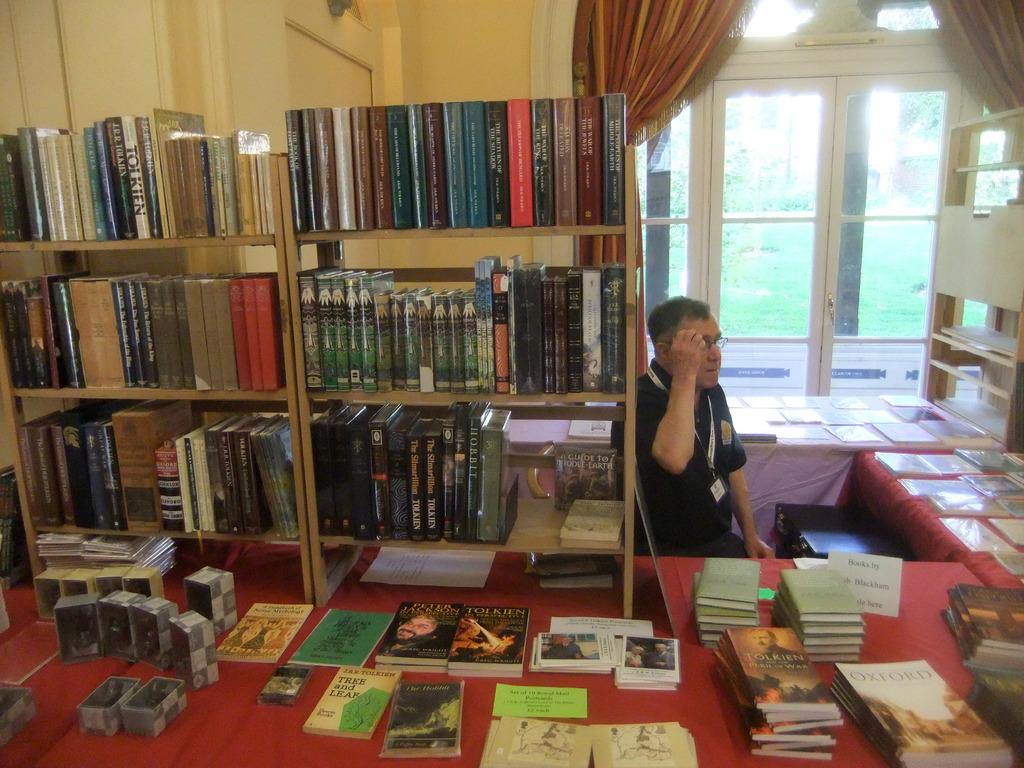<image>
Summarize the visual content of the image. man standing at tables set up displaying books one of which is j.r.r. tolkien's tree and leaf 